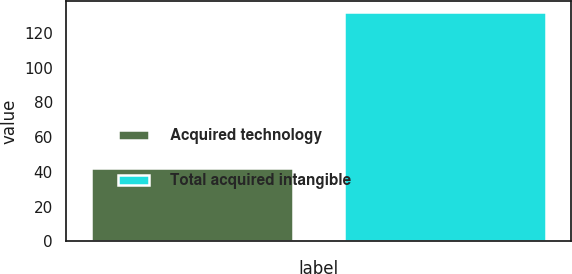Convert chart. <chart><loc_0><loc_0><loc_500><loc_500><bar_chart><fcel>Acquired technology<fcel>Total acquired intangible<nl><fcel>42<fcel>132<nl></chart> 